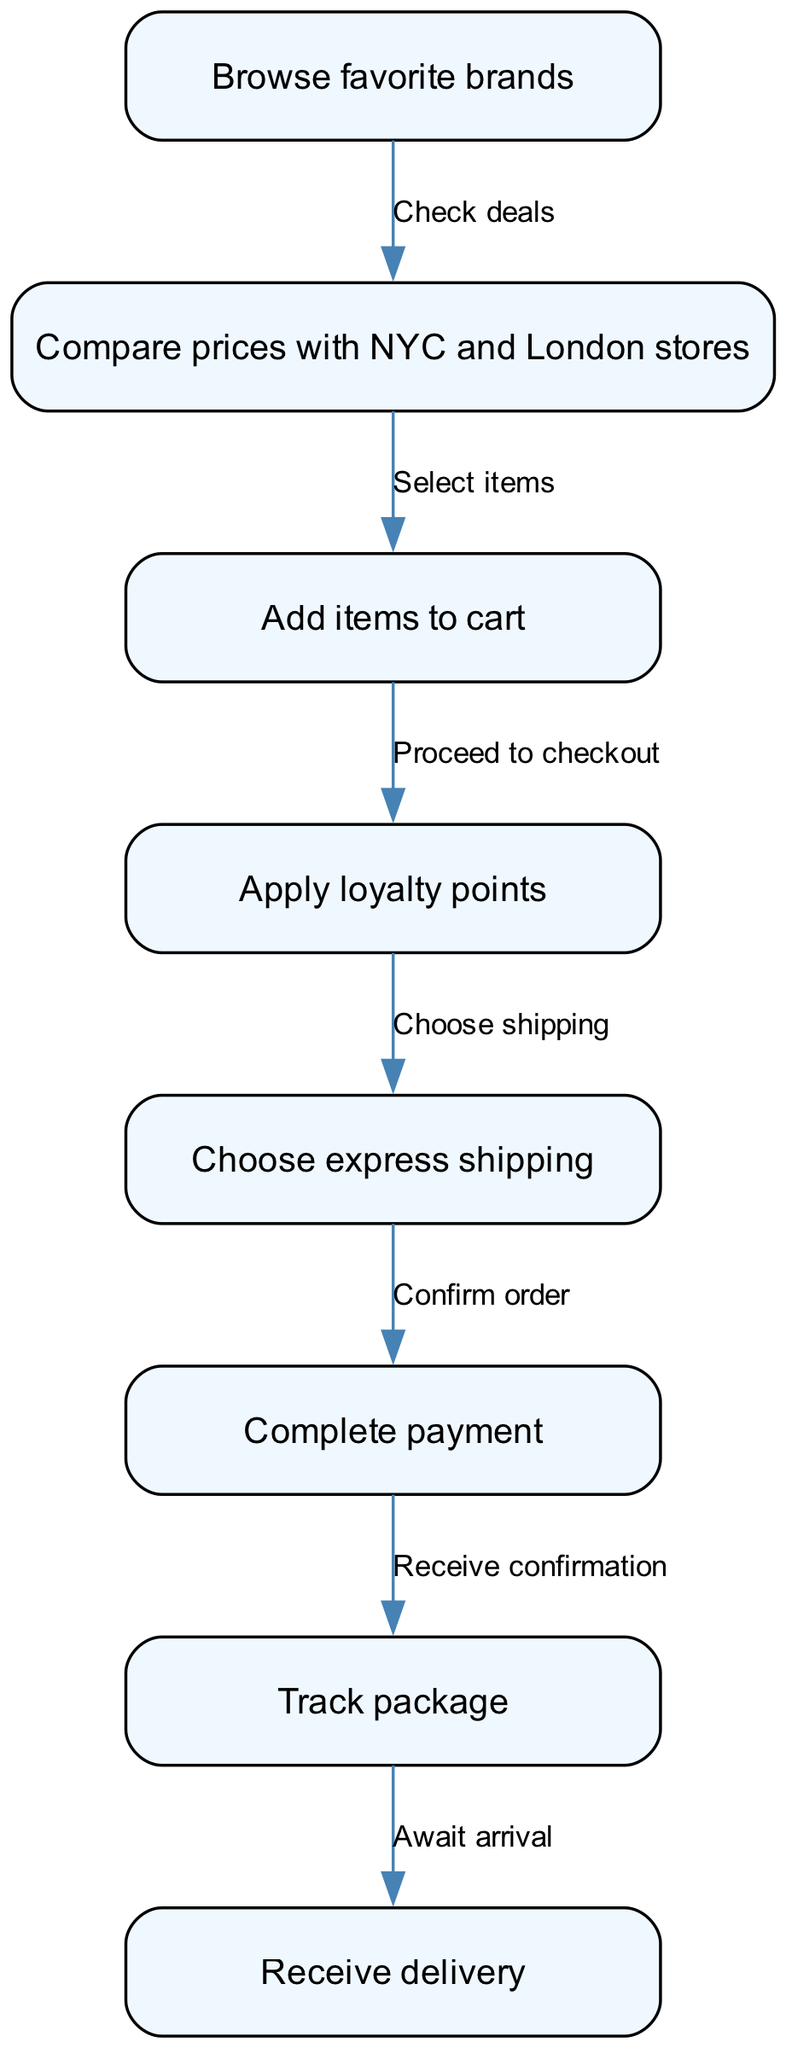What is the first step in the online shopping process? The first step represented in the diagram is "Browse favorite brands," which is the initial action a shopper takes.
Answer: Browse favorite brands How many nodes are in the diagram? By counting each distinct element in the list of nodes provided, we see there are a total of 8 nodes representing different steps in the online shopping process.
Answer: 8 What is the last step before delivery? The last step before receiving delivery is "Track package," indicating the action taken to monitor the status of the order.
Answer: Track package What do you do after adding items to the cart? After adding items to the cart, the next step, as shown in the diagram, is to "Proceed to checkout," which is the action of preparing to finalize the purchase.
Answer: Proceed to checkout How many edges connect "Choose express shipping" to other nodes? By analyzing the edges connected to the "Choose express shipping" node, we note there is one outgoing edge that leads to the "Complete payment" node, indicating a single subsequent action.
Answer: 1 What is the relationship between "Compare prices with NYC and London stores" and "Select items"? The relationship is indicated by a directed edge labeled "Select items," which signifies that after comparing prices, the action taken is to choose specific items.
Answer: Select items What happens after you complete payment? Following the action of completing payment, the subsequent step is "Receive confirmation," depicting the acknowledgment of the order by the online store.
Answer: Receive confirmation What do you choose after applying loyalty points? After applying loyalty points, the next action is to "Choose express shipping," which allows for faster delivery options based on the loyalty benefits.
Answer: Choose express shipping Which step includes checking for deals? The step that involves checking for deals is "Browse favorite brands," as it starts the process of evaluating offers from different brands.
Answer: Browse favorite brands 